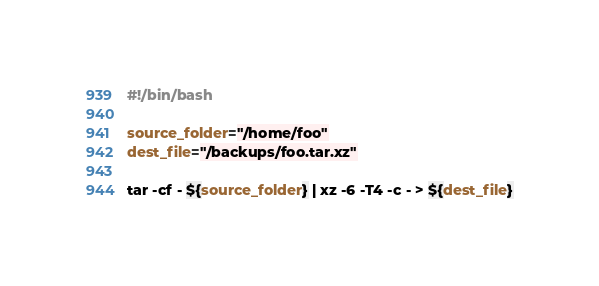Convert code to text. <code><loc_0><loc_0><loc_500><loc_500><_Bash_>#!/bin/bash

source_folder="/home/foo"
dest_file="/backups/foo.tar.xz"

tar -cf - ${source_folder} | xz -6 -T4 -c - > ${dest_file}
</code> 